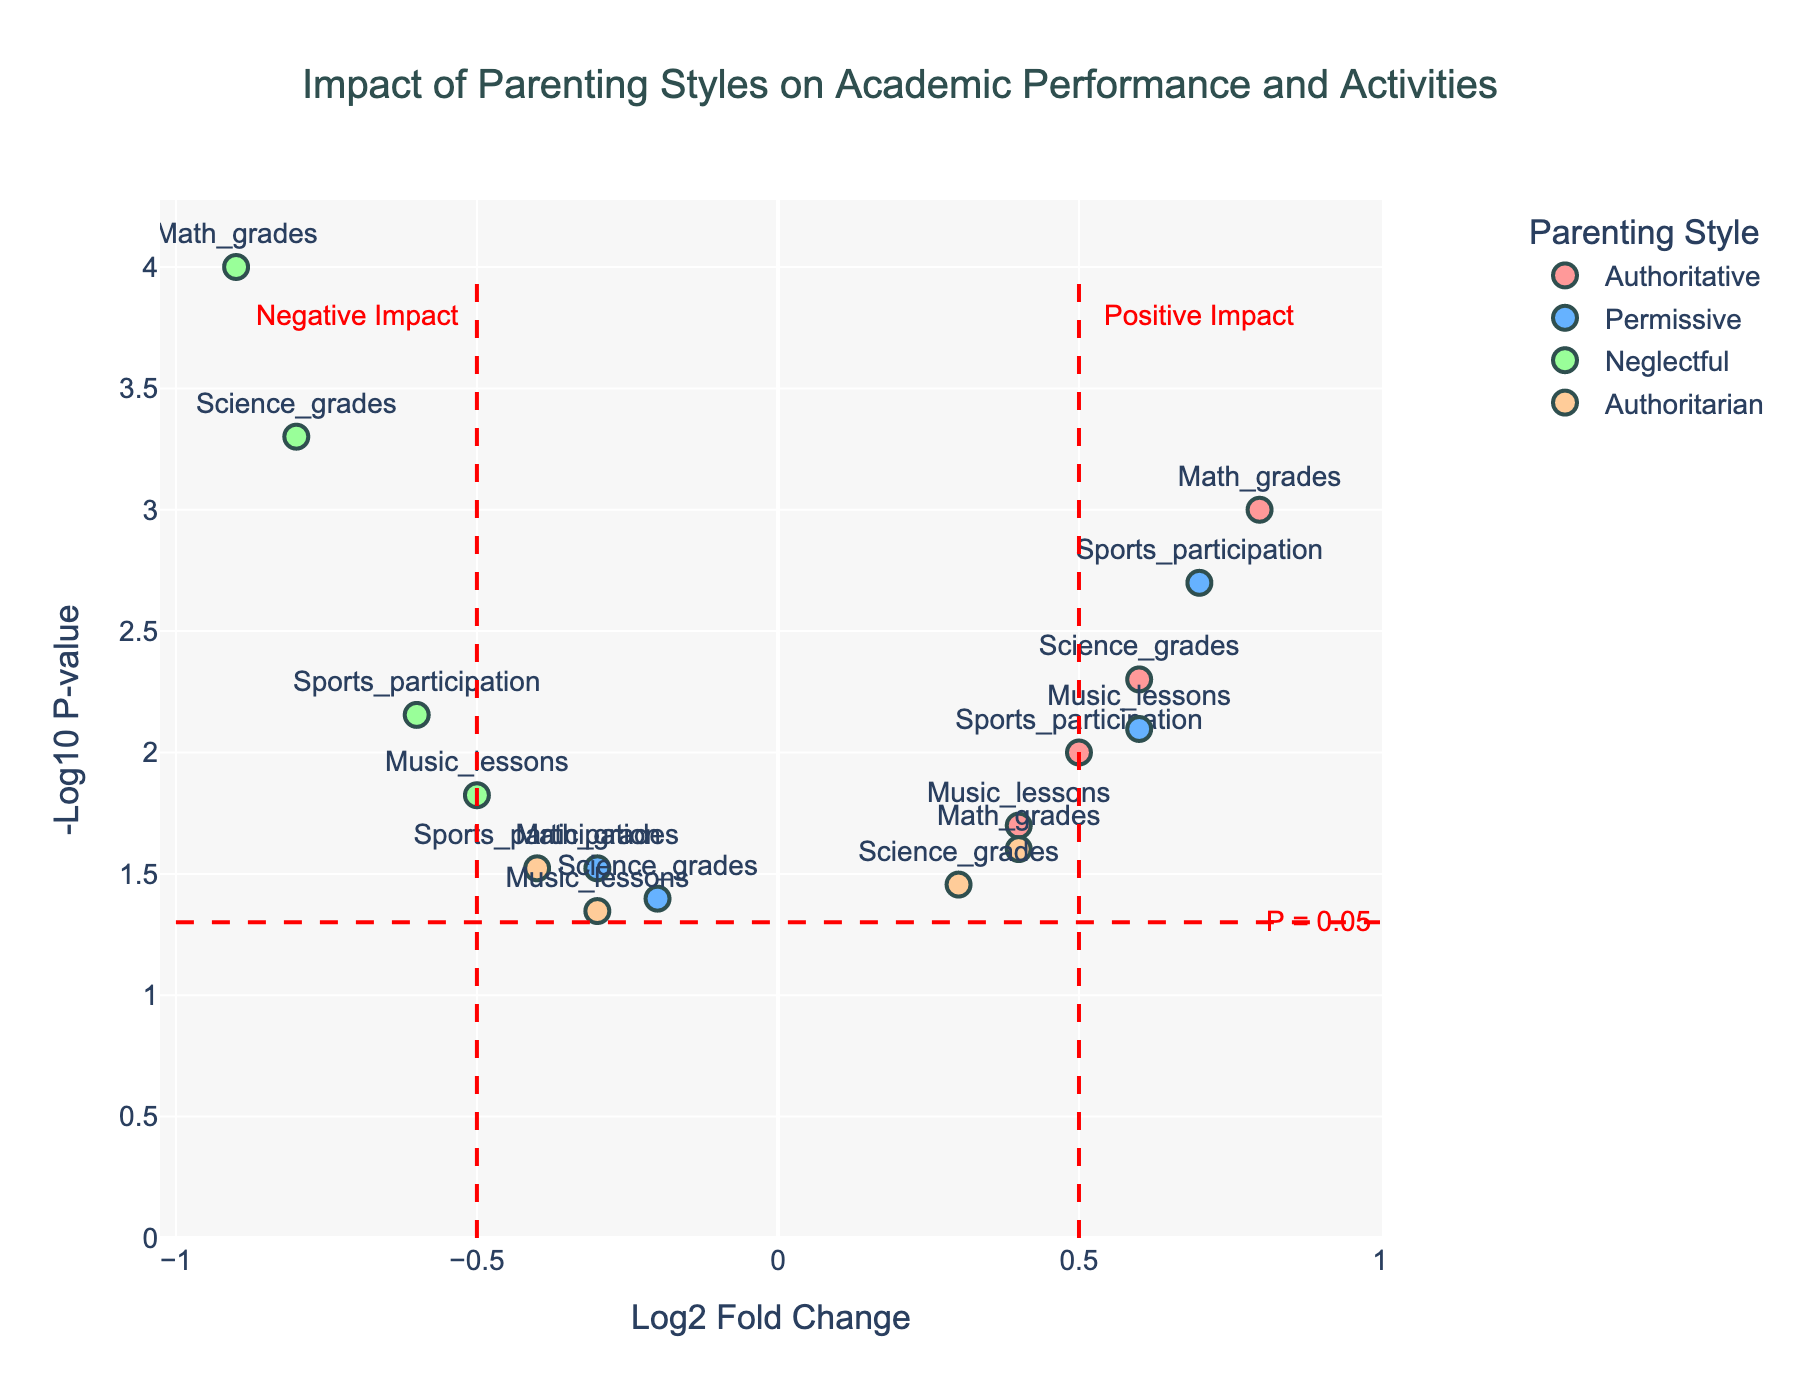How many parenting styles are represented in the plot? By observing the plot legend, which lists the parenting styles, we can see that there are four distinct styles.
Answer: Four Which parenting style has the most positive impact on Math grades based on Log2 Fold Change? By identifying the highest positive Log2 Fold Change value for Math grades in the plot, we observe that Authoritative parenting has the highest value.
Answer: Authoritative What color represents the "Permissive" parenting style in the plot? By referencing the plot legend, we can see that the color used for the Permissive parenting style is light blue.
Answer: Light Blue Compare the impact of Authoritarian and Neglectful parenting styles on Science grades. Which has a higher Log2 Fold Change? By locating and comparing the Log2 Fold Change values for Science grades under both styles, we find Authoritarian has a Log2 Fold Change of 0.3, while Neglectful has -0.8. Thus, Authoritarian has a higher value.
Answer: Authoritarian For which activity does "Permissive" parenting style show a significant positive impact (p-value < 0.05)? Checking the p-values for activities under Permissive parenting, we see significant values for Sports participation (0.002) and Music lessons (0.008).
Answer: Sports participation, Music lessons Which activity associated with the Authoritative parenting style has the lowest -log10(p-value)? By examining all activities under the Authoritative style and their -log10(p-value) values, Music lessons have the lowest -log10(p-value) of -log10(0.02).
Answer: Music lessons Are there any activities where Neglectful and Authoritative styles have opposite impacts on Log2 Fold Change? By observing the Log2 Fold Change values across activities for both styles, we see that Math grades have opposite impacts: -0.9 for Neglectful and 0.8 for Authoritative.
Answer: Math grades What line markings on the plot indicate a significant threshold? Notable horizontal and vertical dashed red lines on the plot indicate thresholds. The vertical lines at Log2 Fold Change of -0.5 and 0.5, and the horizontal line at p = 0.05, signify significance thresholds.
Answer: Red dashed lines Which parenting style shows the most negative impact on Music lessons? Referring to the plot, Neglectful parenting style has the most negative Log2 Fold Change value for Music lessons.
Answer: Neglectful 